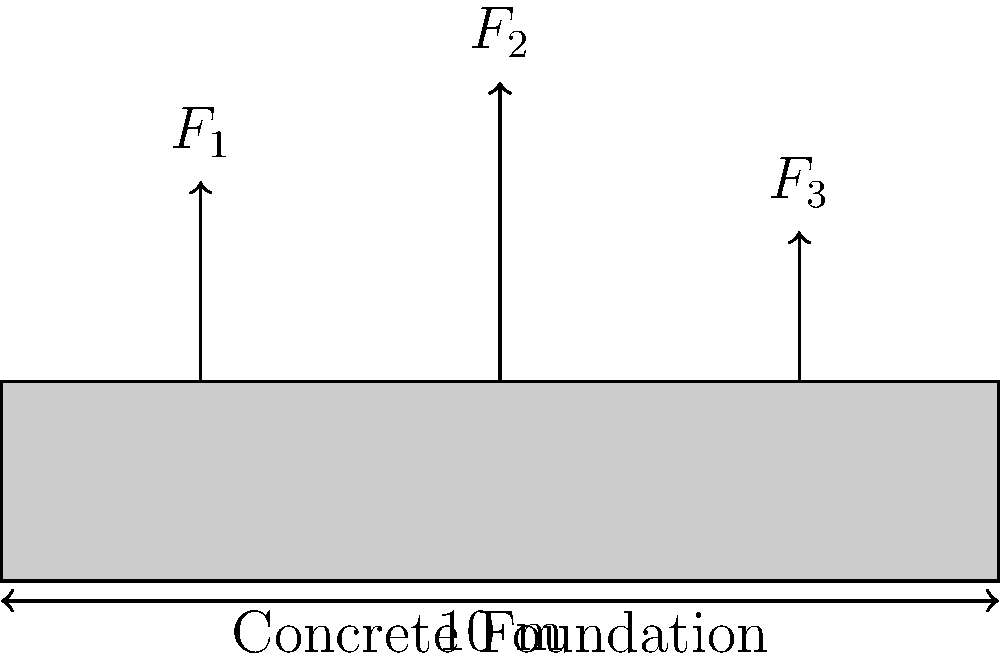As you're showing the engineer's children the construction site, you explain the concept of stress distribution in the concrete foundation. The foundation is 10 meters long and subjected to three point loads $F_1 = 200$ kN, $F_2 = 300$ kN, and $F_3 = 150$ kN at 2 m, 5 m, and 8 m from the left edge, respectively. Assuming a linear stress distribution, calculate the maximum stress $\sigma_{max}$ (in kPa) at the base of the foundation if its width is 3 meters. To solve this problem, we'll follow these steps:

1) First, calculate the total force:
   $F_{total} = F_1 + F_2 + F_3 = 200 + 300 + 150 = 650$ kN

2) Calculate the moment about the left edge:
   $M = (200 \cdot 2) + (300 \cdot 5) + (150 \cdot 8) = 3000$ kN·m

3) Find the centroid of the forces:
   $\bar{x} = \frac{M}{F_{total}} = \frac{3000}{650} = 4.615$ m

4) The eccentricity is the distance from the center of the foundation to the centroid:
   $e = |\frac{10}{2} - 4.615| = 0.385$ m

5) Calculate the area of the foundation:
   $A = 10 \text{ m} \cdot 3 \text{ m} = 30 \text{ m}^2$

6) Calculate the moment of inertia:
   $I = \frac{1}{12} \cdot 3 \text{ m} \cdot (10 \text{ m})^3 = 250 \text{ m}^4$

7) Using the flexure formula, calculate the maximum stress:
   $\sigma_{max} = \frac{F_{total}}{A} + \frac{F_{total} \cdot e \cdot c}{I}$
   where $c = 5 \text{ m}$ (half the length of the foundation)

8) Substitute the values:
   $\sigma_{max} = \frac{650 \text{ kN}}{30 \text{ m}^2} + \frac{650 \text{ kN} \cdot 0.385 \text{ m} \cdot 5 \text{ m}}{250 \text{ m}^4}$

9) Calculate:
   $\sigma_{max} = 21.67 \text{ kN/m}^2 + 25.03 \text{ kN/m}^2 = 46.70 \text{ kN/m}^2 = 46.70 \text{ kPa}$
Answer: 46.70 kPa 